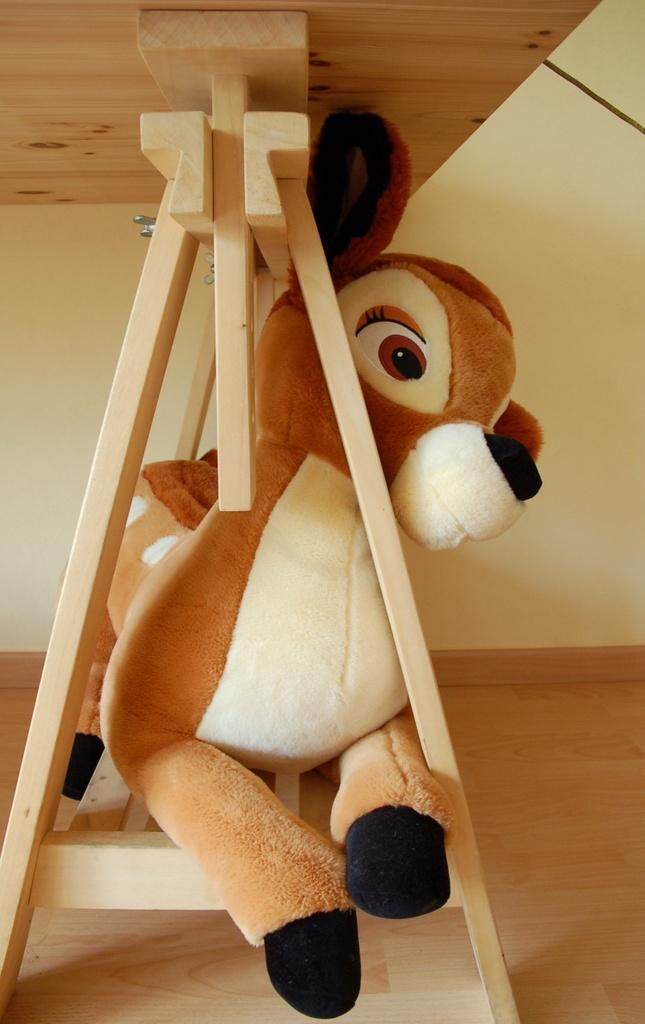What is placed on the wooden stand of the table in the image? There is a doll on a wooden stand of a table in the image. Are there any other dolls visible in the image? Yes, there is another doll on the backside in the image. How many tomatoes are on the table in the image? There are no tomatoes present in the image; it features two dolls on a table. What type of test is being conducted in the image? There is no test being conducted in the image; it features two dolls on a table. 